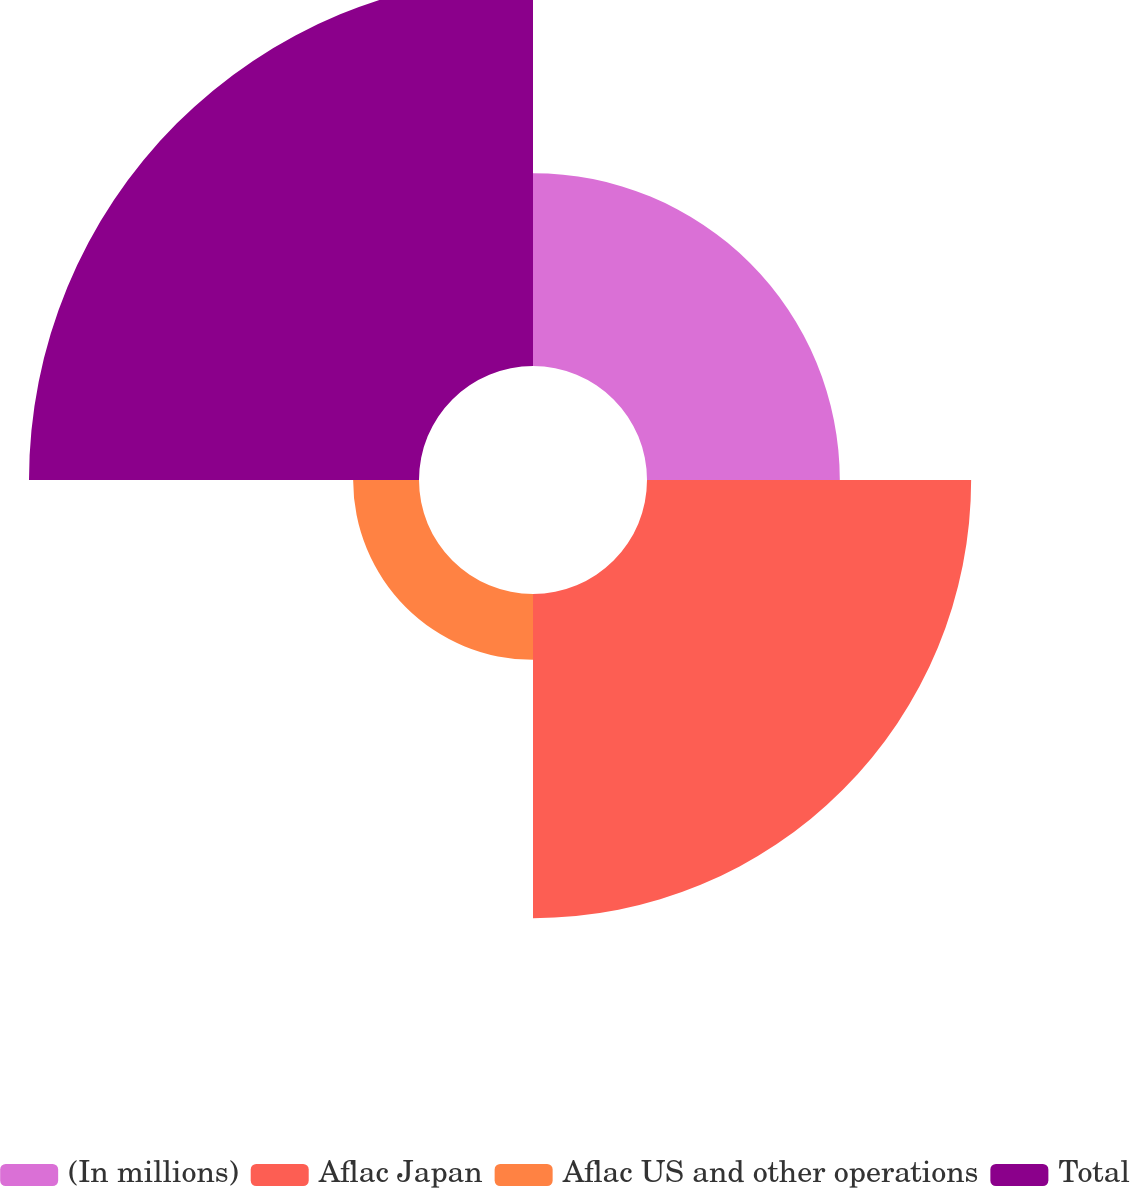<chart> <loc_0><loc_0><loc_500><loc_500><pie_chart><fcel>(In millions)<fcel>Aflac Japan<fcel>Aflac US and other operations<fcel>Total<nl><fcel>19.82%<fcel>33.32%<fcel>6.77%<fcel>40.09%<nl></chart> 